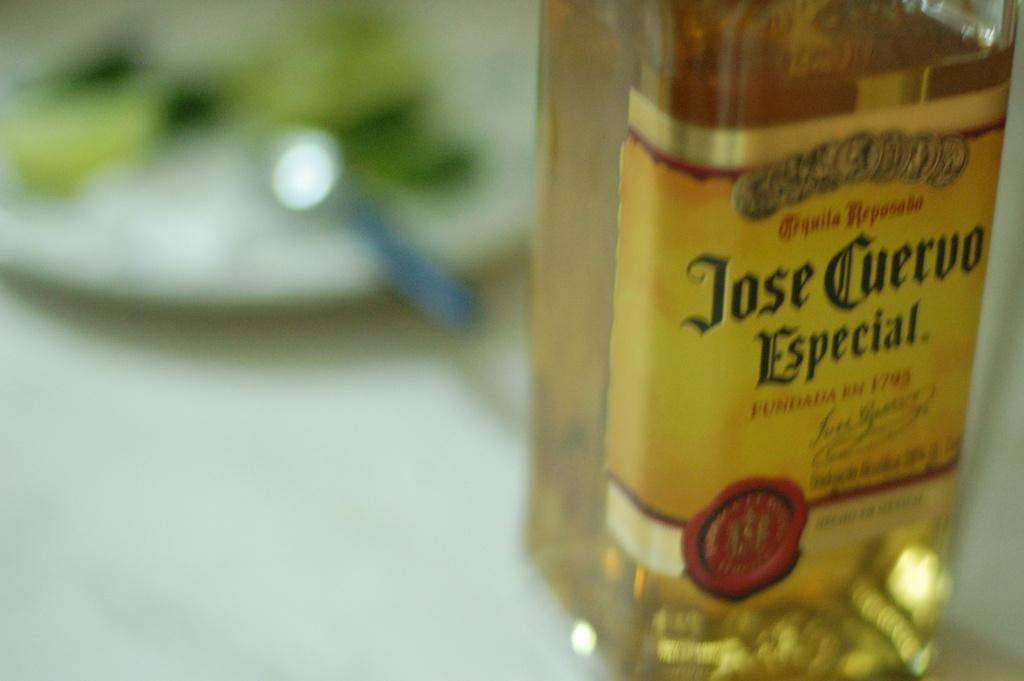<image>
Give a short and clear explanation of the subsequent image. A bottle of Jose Cuervo tequila sits on a white surface. 